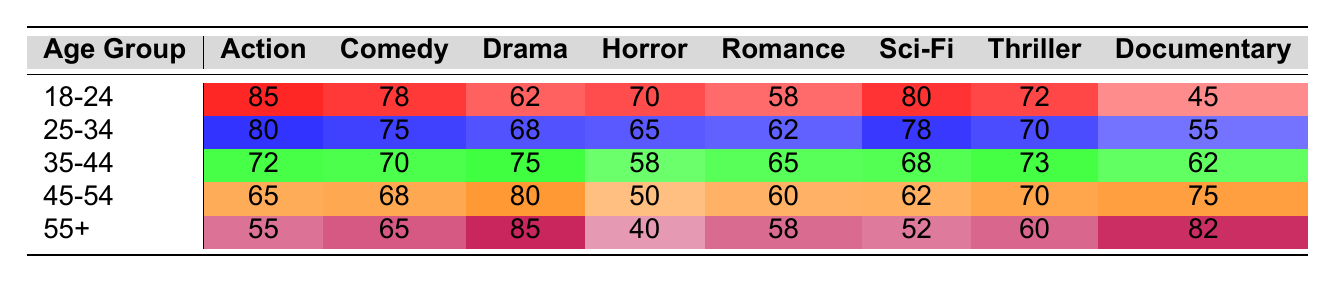What is the most preferred genre among the 18-24 age group? In the 18-24 age group, the highest value is for Action, which is 85.
Answer: Action Which genre has the least preference among the 55+ age group? The least preferred genre in the 55+ age group is Horror, with a value of 40.
Answer: Horror What is the average preference for Drama across all age groups? The sum of the Drama preferences across age groups is 62 + 68 + 75 + 80 + 85 = 370. There are 5 age groups, so the average is 370/5 = 74.
Answer: 74 In which age group is the preference for Comedy closest to the preference for Sci-Fi? For 25-34, Comedy is valued at 75 and Sci-Fi at 78, which makes them closest among the age groups compared.
Answer: 25-34 Is the preference for Documentary higher in the 45-54 age group than in the 35-44 age group? The Documentary preference in the 45-54 group is 75, while in the 35-44 group it is 62. Since 75 > 62, the statement is true.
Answer: Yes Which age group experienced the greatest drop in preference for Action from the 18-24 age group to the 55+ age group? The Action preferences are 85 for 18-24 and 55 for 55+, thus the drop is 85 - 55 = 30. This is the greatest drop among the age groups.
Answer: 30 What is the sum of preferences for Horror across all age groups? The preferences for Horror in each age group are 70 (18-24), 65 (25-34), 58 (35-44), 50 (45-54), and 40 (55+). Summing these gives 70 + 65 + 58 + 50 + 40 = 283.
Answer: 283 Is there any age group where the preference for Thriller is greater than that for Drama? In the 35-44 age group, the preference for Thriller is 73, while for Drama it is 75. In contrast, in the 45-54 age group, Thriller is 70, while for Drama it is 80. Thus, there is no age group with Thriller preference above Drama.
Answer: No How does the preference for Sci-Fi compare between the 25-34 and 45-54 age groups? The 25-34 age group has a Sci-Fi preference of 78, while the 45-54 age group has 62. 78 is greater than 62.
Answer: 25-34 is higher What is the combined preference for Romance and Comedy in the 35-44 age group? The preferences in the 35-44 age group are 65 for Romance and 70 for Comedy. Thus, the combined preference is 65 + 70 = 135.
Answer: 135 